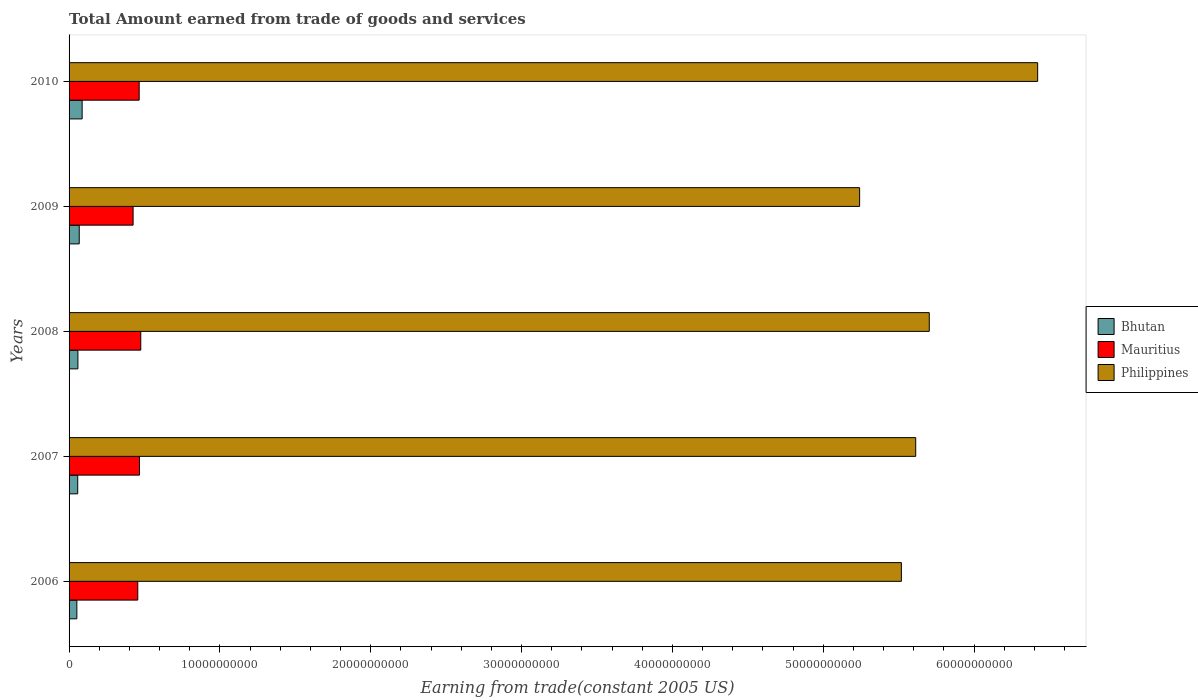How many different coloured bars are there?
Your answer should be compact. 3. Are the number of bars on each tick of the Y-axis equal?
Your response must be concise. Yes. How many bars are there on the 2nd tick from the top?
Your answer should be compact. 3. How many bars are there on the 3rd tick from the bottom?
Offer a very short reply. 3. In how many cases, is the number of bars for a given year not equal to the number of legend labels?
Give a very brief answer. 0. What is the total amount earned by trading goods and services in Philippines in 2010?
Your answer should be very brief. 6.42e+1. Across all years, what is the maximum total amount earned by trading goods and services in Philippines?
Ensure brevity in your answer.  6.42e+1. Across all years, what is the minimum total amount earned by trading goods and services in Mauritius?
Your response must be concise. 4.24e+09. In which year was the total amount earned by trading goods and services in Philippines maximum?
Your answer should be compact. 2010. In which year was the total amount earned by trading goods and services in Philippines minimum?
Make the answer very short. 2009. What is the total total amount earned by trading goods and services in Philippines in the graph?
Offer a very short reply. 2.85e+11. What is the difference between the total amount earned by trading goods and services in Philippines in 2008 and that in 2010?
Ensure brevity in your answer.  -7.19e+09. What is the difference between the total amount earned by trading goods and services in Bhutan in 2008 and the total amount earned by trading goods and services in Philippines in 2007?
Provide a succinct answer. -5.55e+1. What is the average total amount earned by trading goods and services in Mauritius per year?
Your response must be concise. 4.57e+09. In the year 2009, what is the difference between the total amount earned by trading goods and services in Bhutan and total amount earned by trading goods and services in Philippines?
Your answer should be compact. -5.17e+1. What is the ratio of the total amount earned by trading goods and services in Mauritius in 2006 to that in 2008?
Your answer should be very brief. 0.96. Is the difference between the total amount earned by trading goods and services in Bhutan in 2007 and 2008 greater than the difference between the total amount earned by trading goods and services in Philippines in 2007 and 2008?
Offer a very short reply. Yes. What is the difference between the highest and the second highest total amount earned by trading goods and services in Philippines?
Keep it short and to the point. 7.19e+09. What is the difference between the highest and the lowest total amount earned by trading goods and services in Mauritius?
Your answer should be very brief. 5.09e+08. In how many years, is the total amount earned by trading goods and services in Mauritius greater than the average total amount earned by trading goods and services in Mauritius taken over all years?
Make the answer very short. 3. Is the sum of the total amount earned by trading goods and services in Bhutan in 2006 and 2008 greater than the maximum total amount earned by trading goods and services in Mauritius across all years?
Your response must be concise. No. What does the 3rd bar from the top in 2010 represents?
Your response must be concise. Bhutan. What does the 1st bar from the bottom in 2008 represents?
Provide a short and direct response. Bhutan. Is it the case that in every year, the sum of the total amount earned by trading goods and services in Philippines and total amount earned by trading goods and services in Mauritius is greater than the total amount earned by trading goods and services in Bhutan?
Your answer should be very brief. Yes. Does the graph contain any zero values?
Make the answer very short. No. How many legend labels are there?
Offer a terse response. 3. How are the legend labels stacked?
Your answer should be compact. Vertical. What is the title of the graph?
Offer a very short reply. Total Amount earned from trade of goods and services. What is the label or title of the X-axis?
Provide a short and direct response. Earning from trade(constant 2005 US). What is the Earning from trade(constant 2005 US) in Bhutan in 2006?
Your answer should be very brief. 5.17e+08. What is the Earning from trade(constant 2005 US) in Mauritius in 2006?
Your answer should be compact. 4.56e+09. What is the Earning from trade(constant 2005 US) of Philippines in 2006?
Your response must be concise. 5.52e+1. What is the Earning from trade(constant 2005 US) of Bhutan in 2007?
Keep it short and to the point. 5.73e+08. What is the Earning from trade(constant 2005 US) in Mauritius in 2007?
Provide a succinct answer. 4.67e+09. What is the Earning from trade(constant 2005 US) in Philippines in 2007?
Provide a short and direct response. 5.61e+1. What is the Earning from trade(constant 2005 US) in Bhutan in 2008?
Make the answer very short. 5.86e+08. What is the Earning from trade(constant 2005 US) in Mauritius in 2008?
Offer a terse response. 4.75e+09. What is the Earning from trade(constant 2005 US) in Philippines in 2008?
Offer a terse response. 5.70e+1. What is the Earning from trade(constant 2005 US) in Bhutan in 2009?
Offer a very short reply. 6.73e+08. What is the Earning from trade(constant 2005 US) of Mauritius in 2009?
Keep it short and to the point. 4.24e+09. What is the Earning from trade(constant 2005 US) in Philippines in 2009?
Ensure brevity in your answer.  5.24e+1. What is the Earning from trade(constant 2005 US) in Bhutan in 2010?
Your response must be concise. 8.67e+08. What is the Earning from trade(constant 2005 US) of Mauritius in 2010?
Make the answer very short. 4.65e+09. What is the Earning from trade(constant 2005 US) in Philippines in 2010?
Keep it short and to the point. 6.42e+1. Across all years, what is the maximum Earning from trade(constant 2005 US) in Bhutan?
Your answer should be compact. 8.67e+08. Across all years, what is the maximum Earning from trade(constant 2005 US) in Mauritius?
Your answer should be very brief. 4.75e+09. Across all years, what is the maximum Earning from trade(constant 2005 US) in Philippines?
Your answer should be compact. 6.42e+1. Across all years, what is the minimum Earning from trade(constant 2005 US) in Bhutan?
Provide a succinct answer. 5.17e+08. Across all years, what is the minimum Earning from trade(constant 2005 US) of Mauritius?
Your answer should be compact. 4.24e+09. Across all years, what is the minimum Earning from trade(constant 2005 US) of Philippines?
Your answer should be compact. 5.24e+1. What is the total Earning from trade(constant 2005 US) of Bhutan in the graph?
Provide a succinct answer. 3.22e+09. What is the total Earning from trade(constant 2005 US) in Mauritius in the graph?
Your answer should be very brief. 2.29e+1. What is the total Earning from trade(constant 2005 US) of Philippines in the graph?
Provide a succinct answer. 2.85e+11. What is the difference between the Earning from trade(constant 2005 US) of Bhutan in 2006 and that in 2007?
Your answer should be very brief. -5.65e+07. What is the difference between the Earning from trade(constant 2005 US) in Mauritius in 2006 and that in 2007?
Your response must be concise. -1.14e+08. What is the difference between the Earning from trade(constant 2005 US) in Philippines in 2006 and that in 2007?
Offer a very short reply. -9.50e+08. What is the difference between the Earning from trade(constant 2005 US) in Bhutan in 2006 and that in 2008?
Offer a very short reply. -6.96e+07. What is the difference between the Earning from trade(constant 2005 US) in Mauritius in 2006 and that in 2008?
Your answer should be very brief. -1.98e+08. What is the difference between the Earning from trade(constant 2005 US) in Philippines in 2006 and that in 2008?
Provide a succinct answer. -1.85e+09. What is the difference between the Earning from trade(constant 2005 US) of Bhutan in 2006 and that in 2009?
Give a very brief answer. -1.57e+08. What is the difference between the Earning from trade(constant 2005 US) of Mauritius in 2006 and that in 2009?
Your response must be concise. 3.11e+08. What is the difference between the Earning from trade(constant 2005 US) of Philippines in 2006 and that in 2009?
Offer a very short reply. 2.77e+09. What is the difference between the Earning from trade(constant 2005 US) in Bhutan in 2006 and that in 2010?
Your response must be concise. -3.50e+08. What is the difference between the Earning from trade(constant 2005 US) of Mauritius in 2006 and that in 2010?
Offer a terse response. -9.26e+07. What is the difference between the Earning from trade(constant 2005 US) of Philippines in 2006 and that in 2010?
Keep it short and to the point. -9.04e+09. What is the difference between the Earning from trade(constant 2005 US) of Bhutan in 2007 and that in 2008?
Ensure brevity in your answer.  -1.31e+07. What is the difference between the Earning from trade(constant 2005 US) in Mauritius in 2007 and that in 2008?
Your answer should be very brief. -8.40e+07. What is the difference between the Earning from trade(constant 2005 US) in Philippines in 2007 and that in 2008?
Your response must be concise. -8.98e+08. What is the difference between the Earning from trade(constant 2005 US) of Bhutan in 2007 and that in 2009?
Provide a short and direct response. -1.00e+08. What is the difference between the Earning from trade(constant 2005 US) of Mauritius in 2007 and that in 2009?
Provide a short and direct response. 4.25e+08. What is the difference between the Earning from trade(constant 2005 US) in Philippines in 2007 and that in 2009?
Offer a terse response. 3.72e+09. What is the difference between the Earning from trade(constant 2005 US) in Bhutan in 2007 and that in 2010?
Your answer should be compact. -2.94e+08. What is the difference between the Earning from trade(constant 2005 US) of Mauritius in 2007 and that in 2010?
Give a very brief answer. 2.13e+07. What is the difference between the Earning from trade(constant 2005 US) of Philippines in 2007 and that in 2010?
Provide a succinct answer. -8.09e+09. What is the difference between the Earning from trade(constant 2005 US) of Bhutan in 2008 and that in 2009?
Give a very brief answer. -8.73e+07. What is the difference between the Earning from trade(constant 2005 US) in Mauritius in 2008 and that in 2009?
Give a very brief answer. 5.09e+08. What is the difference between the Earning from trade(constant 2005 US) in Philippines in 2008 and that in 2009?
Keep it short and to the point. 4.62e+09. What is the difference between the Earning from trade(constant 2005 US) in Bhutan in 2008 and that in 2010?
Give a very brief answer. -2.81e+08. What is the difference between the Earning from trade(constant 2005 US) in Mauritius in 2008 and that in 2010?
Your answer should be compact. 1.05e+08. What is the difference between the Earning from trade(constant 2005 US) of Philippines in 2008 and that in 2010?
Make the answer very short. -7.19e+09. What is the difference between the Earning from trade(constant 2005 US) of Bhutan in 2009 and that in 2010?
Offer a terse response. -1.94e+08. What is the difference between the Earning from trade(constant 2005 US) of Mauritius in 2009 and that in 2010?
Offer a terse response. -4.03e+08. What is the difference between the Earning from trade(constant 2005 US) of Philippines in 2009 and that in 2010?
Make the answer very short. -1.18e+1. What is the difference between the Earning from trade(constant 2005 US) in Bhutan in 2006 and the Earning from trade(constant 2005 US) in Mauritius in 2007?
Offer a terse response. -4.15e+09. What is the difference between the Earning from trade(constant 2005 US) of Bhutan in 2006 and the Earning from trade(constant 2005 US) of Philippines in 2007?
Give a very brief answer. -5.56e+1. What is the difference between the Earning from trade(constant 2005 US) in Mauritius in 2006 and the Earning from trade(constant 2005 US) in Philippines in 2007?
Offer a terse response. -5.16e+1. What is the difference between the Earning from trade(constant 2005 US) of Bhutan in 2006 and the Earning from trade(constant 2005 US) of Mauritius in 2008?
Provide a succinct answer. -4.24e+09. What is the difference between the Earning from trade(constant 2005 US) in Bhutan in 2006 and the Earning from trade(constant 2005 US) in Philippines in 2008?
Make the answer very short. -5.65e+1. What is the difference between the Earning from trade(constant 2005 US) of Mauritius in 2006 and the Earning from trade(constant 2005 US) of Philippines in 2008?
Keep it short and to the point. -5.25e+1. What is the difference between the Earning from trade(constant 2005 US) of Bhutan in 2006 and the Earning from trade(constant 2005 US) of Mauritius in 2009?
Make the answer very short. -3.73e+09. What is the difference between the Earning from trade(constant 2005 US) of Bhutan in 2006 and the Earning from trade(constant 2005 US) of Philippines in 2009?
Offer a very short reply. -5.19e+1. What is the difference between the Earning from trade(constant 2005 US) of Mauritius in 2006 and the Earning from trade(constant 2005 US) of Philippines in 2009?
Keep it short and to the point. -4.79e+1. What is the difference between the Earning from trade(constant 2005 US) of Bhutan in 2006 and the Earning from trade(constant 2005 US) of Mauritius in 2010?
Ensure brevity in your answer.  -4.13e+09. What is the difference between the Earning from trade(constant 2005 US) of Bhutan in 2006 and the Earning from trade(constant 2005 US) of Philippines in 2010?
Your answer should be compact. -6.37e+1. What is the difference between the Earning from trade(constant 2005 US) of Mauritius in 2006 and the Earning from trade(constant 2005 US) of Philippines in 2010?
Ensure brevity in your answer.  -5.97e+1. What is the difference between the Earning from trade(constant 2005 US) in Bhutan in 2007 and the Earning from trade(constant 2005 US) in Mauritius in 2008?
Give a very brief answer. -4.18e+09. What is the difference between the Earning from trade(constant 2005 US) in Bhutan in 2007 and the Earning from trade(constant 2005 US) in Philippines in 2008?
Keep it short and to the point. -5.65e+1. What is the difference between the Earning from trade(constant 2005 US) in Mauritius in 2007 and the Earning from trade(constant 2005 US) in Philippines in 2008?
Your answer should be compact. -5.24e+1. What is the difference between the Earning from trade(constant 2005 US) of Bhutan in 2007 and the Earning from trade(constant 2005 US) of Mauritius in 2009?
Keep it short and to the point. -3.67e+09. What is the difference between the Earning from trade(constant 2005 US) in Bhutan in 2007 and the Earning from trade(constant 2005 US) in Philippines in 2009?
Offer a terse response. -5.18e+1. What is the difference between the Earning from trade(constant 2005 US) of Mauritius in 2007 and the Earning from trade(constant 2005 US) of Philippines in 2009?
Your answer should be very brief. -4.77e+1. What is the difference between the Earning from trade(constant 2005 US) of Bhutan in 2007 and the Earning from trade(constant 2005 US) of Mauritius in 2010?
Make the answer very short. -4.07e+09. What is the difference between the Earning from trade(constant 2005 US) in Bhutan in 2007 and the Earning from trade(constant 2005 US) in Philippines in 2010?
Ensure brevity in your answer.  -6.36e+1. What is the difference between the Earning from trade(constant 2005 US) of Mauritius in 2007 and the Earning from trade(constant 2005 US) of Philippines in 2010?
Ensure brevity in your answer.  -5.96e+1. What is the difference between the Earning from trade(constant 2005 US) of Bhutan in 2008 and the Earning from trade(constant 2005 US) of Mauritius in 2009?
Ensure brevity in your answer.  -3.66e+09. What is the difference between the Earning from trade(constant 2005 US) of Bhutan in 2008 and the Earning from trade(constant 2005 US) of Philippines in 2009?
Offer a very short reply. -5.18e+1. What is the difference between the Earning from trade(constant 2005 US) in Mauritius in 2008 and the Earning from trade(constant 2005 US) in Philippines in 2009?
Offer a terse response. -4.77e+1. What is the difference between the Earning from trade(constant 2005 US) of Bhutan in 2008 and the Earning from trade(constant 2005 US) of Mauritius in 2010?
Your response must be concise. -4.06e+09. What is the difference between the Earning from trade(constant 2005 US) of Bhutan in 2008 and the Earning from trade(constant 2005 US) of Philippines in 2010?
Offer a terse response. -6.36e+1. What is the difference between the Earning from trade(constant 2005 US) of Mauritius in 2008 and the Earning from trade(constant 2005 US) of Philippines in 2010?
Make the answer very short. -5.95e+1. What is the difference between the Earning from trade(constant 2005 US) in Bhutan in 2009 and the Earning from trade(constant 2005 US) in Mauritius in 2010?
Offer a very short reply. -3.97e+09. What is the difference between the Earning from trade(constant 2005 US) of Bhutan in 2009 and the Earning from trade(constant 2005 US) of Philippines in 2010?
Your answer should be compact. -6.35e+1. What is the difference between the Earning from trade(constant 2005 US) of Mauritius in 2009 and the Earning from trade(constant 2005 US) of Philippines in 2010?
Give a very brief answer. -6.00e+1. What is the average Earning from trade(constant 2005 US) in Bhutan per year?
Your response must be concise. 6.43e+08. What is the average Earning from trade(constant 2005 US) in Mauritius per year?
Your answer should be compact. 4.57e+09. What is the average Earning from trade(constant 2005 US) of Philippines per year?
Give a very brief answer. 5.70e+1. In the year 2006, what is the difference between the Earning from trade(constant 2005 US) of Bhutan and Earning from trade(constant 2005 US) of Mauritius?
Offer a very short reply. -4.04e+09. In the year 2006, what is the difference between the Earning from trade(constant 2005 US) of Bhutan and Earning from trade(constant 2005 US) of Philippines?
Your answer should be compact. -5.47e+1. In the year 2006, what is the difference between the Earning from trade(constant 2005 US) in Mauritius and Earning from trade(constant 2005 US) in Philippines?
Your response must be concise. -5.06e+1. In the year 2007, what is the difference between the Earning from trade(constant 2005 US) in Bhutan and Earning from trade(constant 2005 US) in Mauritius?
Give a very brief answer. -4.10e+09. In the year 2007, what is the difference between the Earning from trade(constant 2005 US) of Bhutan and Earning from trade(constant 2005 US) of Philippines?
Provide a short and direct response. -5.56e+1. In the year 2007, what is the difference between the Earning from trade(constant 2005 US) of Mauritius and Earning from trade(constant 2005 US) of Philippines?
Make the answer very short. -5.15e+1. In the year 2008, what is the difference between the Earning from trade(constant 2005 US) in Bhutan and Earning from trade(constant 2005 US) in Mauritius?
Provide a short and direct response. -4.17e+09. In the year 2008, what is the difference between the Earning from trade(constant 2005 US) of Bhutan and Earning from trade(constant 2005 US) of Philippines?
Offer a terse response. -5.64e+1. In the year 2008, what is the difference between the Earning from trade(constant 2005 US) in Mauritius and Earning from trade(constant 2005 US) in Philippines?
Ensure brevity in your answer.  -5.23e+1. In the year 2009, what is the difference between the Earning from trade(constant 2005 US) in Bhutan and Earning from trade(constant 2005 US) in Mauritius?
Ensure brevity in your answer.  -3.57e+09. In the year 2009, what is the difference between the Earning from trade(constant 2005 US) in Bhutan and Earning from trade(constant 2005 US) in Philippines?
Provide a short and direct response. -5.17e+1. In the year 2009, what is the difference between the Earning from trade(constant 2005 US) of Mauritius and Earning from trade(constant 2005 US) of Philippines?
Make the answer very short. -4.82e+1. In the year 2010, what is the difference between the Earning from trade(constant 2005 US) of Bhutan and Earning from trade(constant 2005 US) of Mauritius?
Your answer should be very brief. -3.78e+09. In the year 2010, what is the difference between the Earning from trade(constant 2005 US) of Bhutan and Earning from trade(constant 2005 US) of Philippines?
Your answer should be very brief. -6.34e+1. In the year 2010, what is the difference between the Earning from trade(constant 2005 US) in Mauritius and Earning from trade(constant 2005 US) in Philippines?
Your response must be concise. -5.96e+1. What is the ratio of the Earning from trade(constant 2005 US) in Bhutan in 2006 to that in 2007?
Ensure brevity in your answer.  0.9. What is the ratio of the Earning from trade(constant 2005 US) in Mauritius in 2006 to that in 2007?
Your answer should be very brief. 0.98. What is the ratio of the Earning from trade(constant 2005 US) in Philippines in 2006 to that in 2007?
Provide a succinct answer. 0.98. What is the ratio of the Earning from trade(constant 2005 US) of Bhutan in 2006 to that in 2008?
Provide a short and direct response. 0.88. What is the ratio of the Earning from trade(constant 2005 US) in Mauritius in 2006 to that in 2008?
Ensure brevity in your answer.  0.96. What is the ratio of the Earning from trade(constant 2005 US) of Philippines in 2006 to that in 2008?
Keep it short and to the point. 0.97. What is the ratio of the Earning from trade(constant 2005 US) of Bhutan in 2006 to that in 2009?
Your answer should be very brief. 0.77. What is the ratio of the Earning from trade(constant 2005 US) in Mauritius in 2006 to that in 2009?
Keep it short and to the point. 1.07. What is the ratio of the Earning from trade(constant 2005 US) in Philippines in 2006 to that in 2009?
Ensure brevity in your answer.  1.05. What is the ratio of the Earning from trade(constant 2005 US) of Bhutan in 2006 to that in 2010?
Ensure brevity in your answer.  0.6. What is the ratio of the Earning from trade(constant 2005 US) of Mauritius in 2006 to that in 2010?
Make the answer very short. 0.98. What is the ratio of the Earning from trade(constant 2005 US) of Philippines in 2006 to that in 2010?
Keep it short and to the point. 0.86. What is the ratio of the Earning from trade(constant 2005 US) in Bhutan in 2007 to that in 2008?
Provide a succinct answer. 0.98. What is the ratio of the Earning from trade(constant 2005 US) of Mauritius in 2007 to that in 2008?
Your answer should be compact. 0.98. What is the ratio of the Earning from trade(constant 2005 US) of Philippines in 2007 to that in 2008?
Your answer should be compact. 0.98. What is the ratio of the Earning from trade(constant 2005 US) in Bhutan in 2007 to that in 2009?
Offer a very short reply. 0.85. What is the ratio of the Earning from trade(constant 2005 US) in Philippines in 2007 to that in 2009?
Your answer should be compact. 1.07. What is the ratio of the Earning from trade(constant 2005 US) in Bhutan in 2007 to that in 2010?
Provide a succinct answer. 0.66. What is the ratio of the Earning from trade(constant 2005 US) of Mauritius in 2007 to that in 2010?
Provide a succinct answer. 1. What is the ratio of the Earning from trade(constant 2005 US) of Philippines in 2007 to that in 2010?
Your response must be concise. 0.87. What is the ratio of the Earning from trade(constant 2005 US) in Bhutan in 2008 to that in 2009?
Provide a short and direct response. 0.87. What is the ratio of the Earning from trade(constant 2005 US) of Mauritius in 2008 to that in 2009?
Ensure brevity in your answer.  1.12. What is the ratio of the Earning from trade(constant 2005 US) of Philippines in 2008 to that in 2009?
Your response must be concise. 1.09. What is the ratio of the Earning from trade(constant 2005 US) in Bhutan in 2008 to that in 2010?
Offer a very short reply. 0.68. What is the ratio of the Earning from trade(constant 2005 US) in Mauritius in 2008 to that in 2010?
Offer a terse response. 1.02. What is the ratio of the Earning from trade(constant 2005 US) of Philippines in 2008 to that in 2010?
Give a very brief answer. 0.89. What is the ratio of the Earning from trade(constant 2005 US) of Bhutan in 2009 to that in 2010?
Give a very brief answer. 0.78. What is the ratio of the Earning from trade(constant 2005 US) in Mauritius in 2009 to that in 2010?
Offer a very short reply. 0.91. What is the ratio of the Earning from trade(constant 2005 US) in Philippines in 2009 to that in 2010?
Give a very brief answer. 0.82. What is the difference between the highest and the second highest Earning from trade(constant 2005 US) in Bhutan?
Keep it short and to the point. 1.94e+08. What is the difference between the highest and the second highest Earning from trade(constant 2005 US) of Mauritius?
Provide a short and direct response. 8.40e+07. What is the difference between the highest and the second highest Earning from trade(constant 2005 US) in Philippines?
Keep it short and to the point. 7.19e+09. What is the difference between the highest and the lowest Earning from trade(constant 2005 US) in Bhutan?
Provide a succinct answer. 3.50e+08. What is the difference between the highest and the lowest Earning from trade(constant 2005 US) in Mauritius?
Offer a very short reply. 5.09e+08. What is the difference between the highest and the lowest Earning from trade(constant 2005 US) in Philippines?
Offer a very short reply. 1.18e+1. 